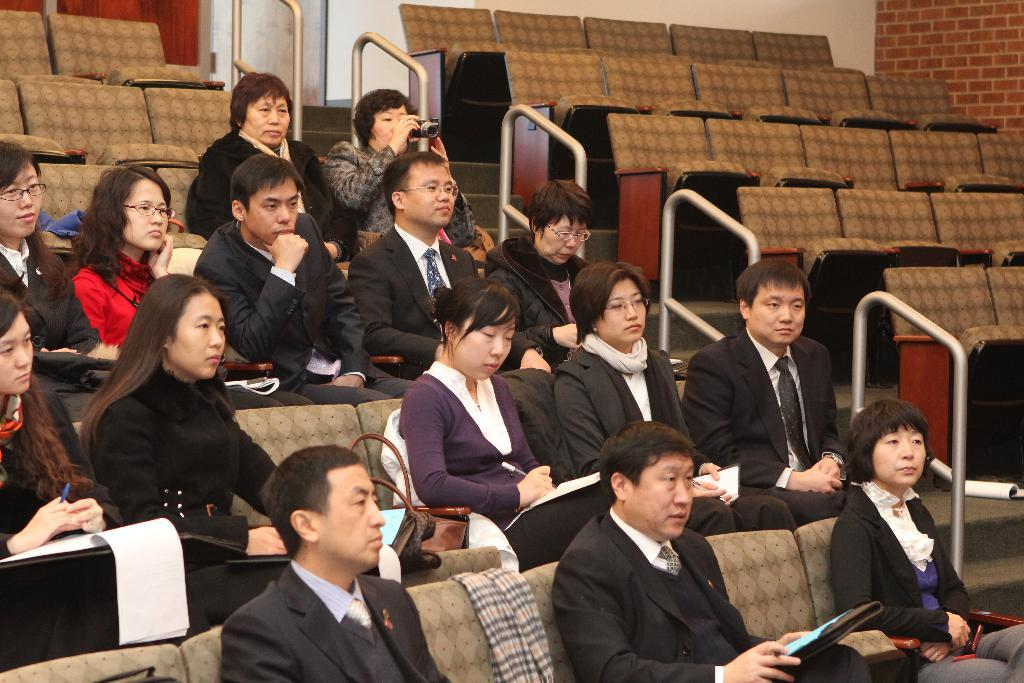What are the people in the image doing? The people in the image are seated on chairs and holding books in their hands. How many people are visible in the image? There are people seated on chairs, and some of them are holding books. Are there any empty chairs in the image? Yes, there are empty chairs visible in the image. What is the woman holding in her hand? The woman is holding a camera in her hand. What type of creature is being taught by the people in the image? There is no creature present in the image; the people are holding books and there is a woman holding a camera. 